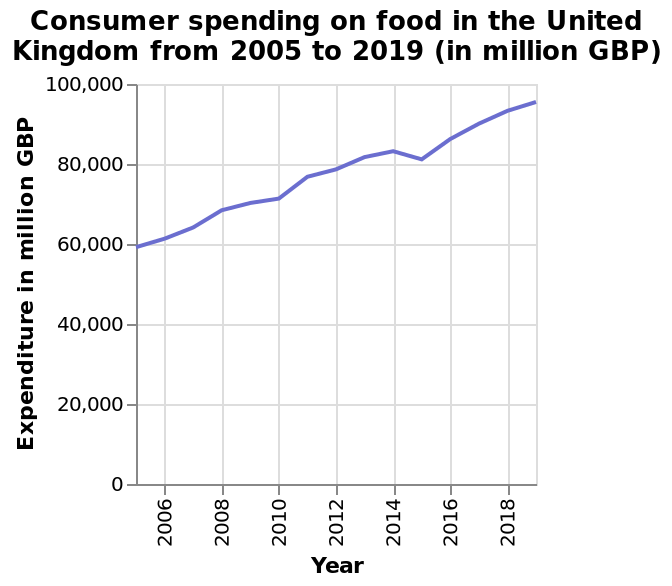<image>
What is the time period covered by the line chart? The line chart covers the years 2005 to 2019. What is the trend observed in the chart regarding food prices and payments? The trend observed in the chart is that both food prices and the amount people are paying for food have increased over the years. 